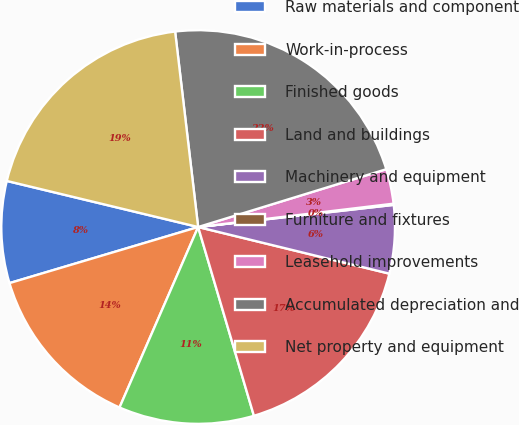Convert chart to OTSL. <chart><loc_0><loc_0><loc_500><loc_500><pie_chart><fcel>Raw materials and component<fcel>Work-in-process<fcel>Finished goods<fcel>Land and buildings<fcel>Machinery and equipment<fcel>Furniture and fixtures<fcel>Leasehold improvements<fcel>Accumulated depreciation and<fcel>Net property and equipment<nl><fcel>8.36%<fcel>13.86%<fcel>11.11%<fcel>16.62%<fcel>5.6%<fcel>0.1%<fcel>2.85%<fcel>22.12%<fcel>19.37%<nl></chart> 